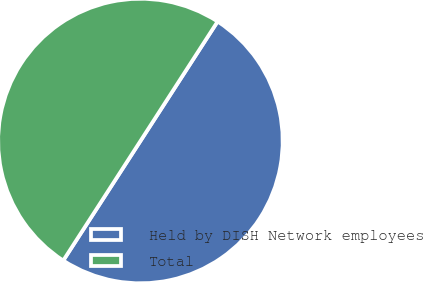Convert chart. <chart><loc_0><loc_0><loc_500><loc_500><pie_chart><fcel>Held by DISH Network employees<fcel>Total<nl><fcel>50.0%<fcel>50.0%<nl></chart> 